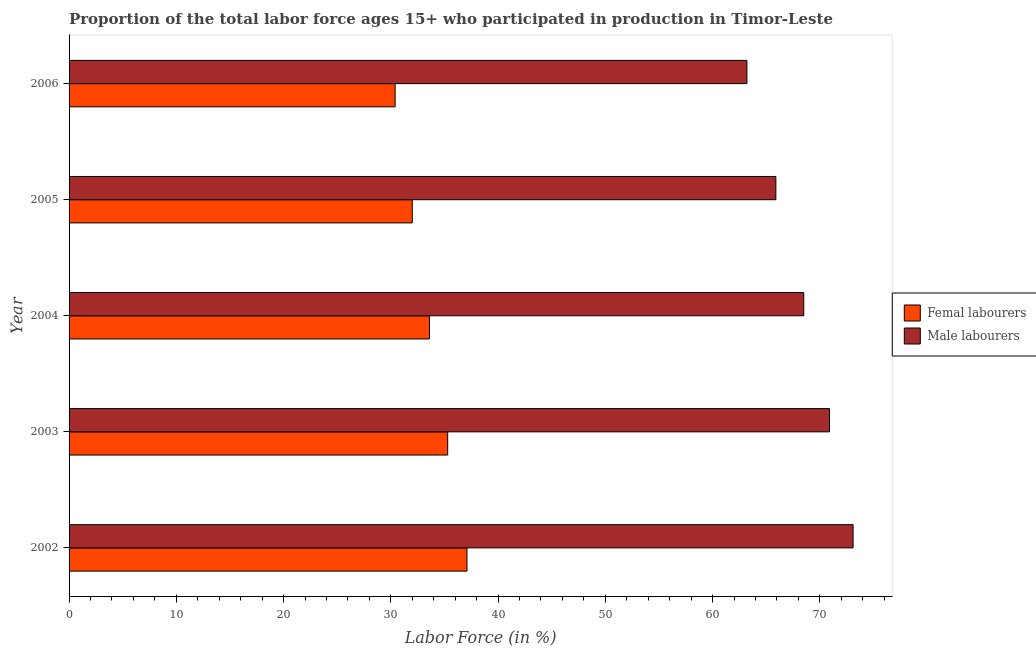How many groups of bars are there?
Provide a short and direct response. 5. Are the number of bars per tick equal to the number of legend labels?
Keep it short and to the point. Yes. Are the number of bars on each tick of the Y-axis equal?
Your response must be concise. Yes. How many bars are there on the 2nd tick from the top?
Provide a short and direct response. 2. How many bars are there on the 2nd tick from the bottom?
Provide a short and direct response. 2. What is the label of the 2nd group of bars from the top?
Your answer should be compact. 2005. In how many cases, is the number of bars for a given year not equal to the number of legend labels?
Offer a terse response. 0. What is the percentage of male labour force in 2002?
Your response must be concise. 73.1. Across all years, what is the maximum percentage of female labor force?
Your answer should be very brief. 37.1. Across all years, what is the minimum percentage of male labour force?
Your answer should be very brief. 63.2. In which year was the percentage of male labour force maximum?
Offer a terse response. 2002. In which year was the percentage of female labor force minimum?
Offer a very short reply. 2006. What is the total percentage of female labor force in the graph?
Offer a very short reply. 168.4. What is the difference between the percentage of male labour force in 2004 and the percentage of female labor force in 2002?
Offer a very short reply. 31.4. What is the average percentage of female labor force per year?
Offer a terse response. 33.68. In the year 2003, what is the difference between the percentage of female labor force and percentage of male labour force?
Make the answer very short. -35.6. What is the ratio of the percentage of female labor force in 2003 to that in 2006?
Offer a very short reply. 1.16. What is the difference between the highest and the second highest percentage of female labor force?
Ensure brevity in your answer.  1.8. What is the difference between the highest and the lowest percentage of female labor force?
Your response must be concise. 6.7. In how many years, is the percentage of female labor force greater than the average percentage of female labor force taken over all years?
Give a very brief answer. 2. What does the 1st bar from the top in 2002 represents?
Your response must be concise. Male labourers. What does the 1st bar from the bottom in 2003 represents?
Ensure brevity in your answer.  Femal labourers. How many bars are there?
Make the answer very short. 10. How many years are there in the graph?
Offer a very short reply. 5. What is the difference between two consecutive major ticks on the X-axis?
Your answer should be compact. 10. Does the graph contain any zero values?
Your response must be concise. No. How many legend labels are there?
Give a very brief answer. 2. What is the title of the graph?
Provide a short and direct response. Proportion of the total labor force ages 15+ who participated in production in Timor-Leste. Does "Merchandise imports" appear as one of the legend labels in the graph?
Your answer should be compact. No. What is the label or title of the Y-axis?
Ensure brevity in your answer.  Year. What is the Labor Force (in %) of Femal labourers in 2002?
Provide a succinct answer. 37.1. What is the Labor Force (in %) in Male labourers in 2002?
Your response must be concise. 73.1. What is the Labor Force (in %) in Femal labourers in 2003?
Offer a terse response. 35.3. What is the Labor Force (in %) of Male labourers in 2003?
Provide a succinct answer. 70.9. What is the Labor Force (in %) in Femal labourers in 2004?
Your response must be concise. 33.6. What is the Labor Force (in %) of Male labourers in 2004?
Provide a succinct answer. 68.5. What is the Labor Force (in %) of Femal labourers in 2005?
Ensure brevity in your answer.  32. What is the Labor Force (in %) of Male labourers in 2005?
Your response must be concise. 65.9. What is the Labor Force (in %) in Femal labourers in 2006?
Your answer should be very brief. 30.4. What is the Labor Force (in %) of Male labourers in 2006?
Keep it short and to the point. 63.2. Across all years, what is the maximum Labor Force (in %) in Femal labourers?
Give a very brief answer. 37.1. Across all years, what is the maximum Labor Force (in %) of Male labourers?
Give a very brief answer. 73.1. Across all years, what is the minimum Labor Force (in %) of Femal labourers?
Offer a terse response. 30.4. Across all years, what is the minimum Labor Force (in %) in Male labourers?
Provide a short and direct response. 63.2. What is the total Labor Force (in %) of Femal labourers in the graph?
Your answer should be compact. 168.4. What is the total Labor Force (in %) in Male labourers in the graph?
Provide a short and direct response. 341.6. What is the difference between the Labor Force (in %) of Femal labourers in 2002 and that in 2005?
Your response must be concise. 5.1. What is the difference between the Labor Force (in %) in Male labourers in 2002 and that in 2005?
Your response must be concise. 7.2. What is the difference between the Labor Force (in %) in Femal labourers in 2002 and that in 2006?
Give a very brief answer. 6.7. What is the difference between the Labor Force (in %) of Male labourers in 2002 and that in 2006?
Offer a very short reply. 9.9. What is the difference between the Labor Force (in %) in Male labourers in 2003 and that in 2004?
Your answer should be compact. 2.4. What is the difference between the Labor Force (in %) in Male labourers in 2003 and that in 2005?
Your answer should be compact. 5. What is the difference between the Labor Force (in %) in Male labourers in 2004 and that in 2005?
Make the answer very short. 2.6. What is the difference between the Labor Force (in %) of Femal labourers in 2002 and the Labor Force (in %) of Male labourers in 2003?
Keep it short and to the point. -33.8. What is the difference between the Labor Force (in %) of Femal labourers in 2002 and the Labor Force (in %) of Male labourers in 2004?
Provide a short and direct response. -31.4. What is the difference between the Labor Force (in %) in Femal labourers in 2002 and the Labor Force (in %) in Male labourers in 2005?
Your answer should be compact. -28.8. What is the difference between the Labor Force (in %) in Femal labourers in 2002 and the Labor Force (in %) in Male labourers in 2006?
Offer a very short reply. -26.1. What is the difference between the Labor Force (in %) of Femal labourers in 2003 and the Labor Force (in %) of Male labourers in 2004?
Keep it short and to the point. -33.2. What is the difference between the Labor Force (in %) of Femal labourers in 2003 and the Labor Force (in %) of Male labourers in 2005?
Your response must be concise. -30.6. What is the difference between the Labor Force (in %) in Femal labourers in 2003 and the Labor Force (in %) in Male labourers in 2006?
Keep it short and to the point. -27.9. What is the difference between the Labor Force (in %) of Femal labourers in 2004 and the Labor Force (in %) of Male labourers in 2005?
Give a very brief answer. -32.3. What is the difference between the Labor Force (in %) in Femal labourers in 2004 and the Labor Force (in %) in Male labourers in 2006?
Make the answer very short. -29.6. What is the difference between the Labor Force (in %) in Femal labourers in 2005 and the Labor Force (in %) in Male labourers in 2006?
Your answer should be very brief. -31.2. What is the average Labor Force (in %) in Femal labourers per year?
Provide a short and direct response. 33.68. What is the average Labor Force (in %) of Male labourers per year?
Offer a very short reply. 68.32. In the year 2002, what is the difference between the Labor Force (in %) in Femal labourers and Labor Force (in %) in Male labourers?
Keep it short and to the point. -36. In the year 2003, what is the difference between the Labor Force (in %) of Femal labourers and Labor Force (in %) of Male labourers?
Make the answer very short. -35.6. In the year 2004, what is the difference between the Labor Force (in %) of Femal labourers and Labor Force (in %) of Male labourers?
Give a very brief answer. -34.9. In the year 2005, what is the difference between the Labor Force (in %) of Femal labourers and Labor Force (in %) of Male labourers?
Provide a short and direct response. -33.9. In the year 2006, what is the difference between the Labor Force (in %) of Femal labourers and Labor Force (in %) of Male labourers?
Give a very brief answer. -32.8. What is the ratio of the Labor Force (in %) of Femal labourers in 2002 to that in 2003?
Give a very brief answer. 1.05. What is the ratio of the Labor Force (in %) of Male labourers in 2002 to that in 2003?
Give a very brief answer. 1.03. What is the ratio of the Labor Force (in %) of Femal labourers in 2002 to that in 2004?
Keep it short and to the point. 1.1. What is the ratio of the Labor Force (in %) in Male labourers in 2002 to that in 2004?
Make the answer very short. 1.07. What is the ratio of the Labor Force (in %) of Femal labourers in 2002 to that in 2005?
Your answer should be compact. 1.16. What is the ratio of the Labor Force (in %) in Male labourers in 2002 to that in 2005?
Your response must be concise. 1.11. What is the ratio of the Labor Force (in %) in Femal labourers in 2002 to that in 2006?
Give a very brief answer. 1.22. What is the ratio of the Labor Force (in %) of Male labourers in 2002 to that in 2006?
Offer a very short reply. 1.16. What is the ratio of the Labor Force (in %) of Femal labourers in 2003 to that in 2004?
Keep it short and to the point. 1.05. What is the ratio of the Labor Force (in %) of Male labourers in 2003 to that in 2004?
Your response must be concise. 1.03. What is the ratio of the Labor Force (in %) in Femal labourers in 2003 to that in 2005?
Make the answer very short. 1.1. What is the ratio of the Labor Force (in %) in Male labourers in 2003 to that in 2005?
Keep it short and to the point. 1.08. What is the ratio of the Labor Force (in %) of Femal labourers in 2003 to that in 2006?
Make the answer very short. 1.16. What is the ratio of the Labor Force (in %) of Male labourers in 2003 to that in 2006?
Offer a terse response. 1.12. What is the ratio of the Labor Force (in %) in Femal labourers in 2004 to that in 2005?
Provide a succinct answer. 1.05. What is the ratio of the Labor Force (in %) of Male labourers in 2004 to that in 2005?
Offer a very short reply. 1.04. What is the ratio of the Labor Force (in %) of Femal labourers in 2004 to that in 2006?
Make the answer very short. 1.11. What is the ratio of the Labor Force (in %) of Male labourers in 2004 to that in 2006?
Offer a very short reply. 1.08. What is the ratio of the Labor Force (in %) in Femal labourers in 2005 to that in 2006?
Make the answer very short. 1.05. What is the ratio of the Labor Force (in %) in Male labourers in 2005 to that in 2006?
Ensure brevity in your answer.  1.04. What is the difference between the highest and the second highest Labor Force (in %) in Male labourers?
Provide a succinct answer. 2.2. What is the difference between the highest and the lowest Labor Force (in %) in Femal labourers?
Your answer should be compact. 6.7. 